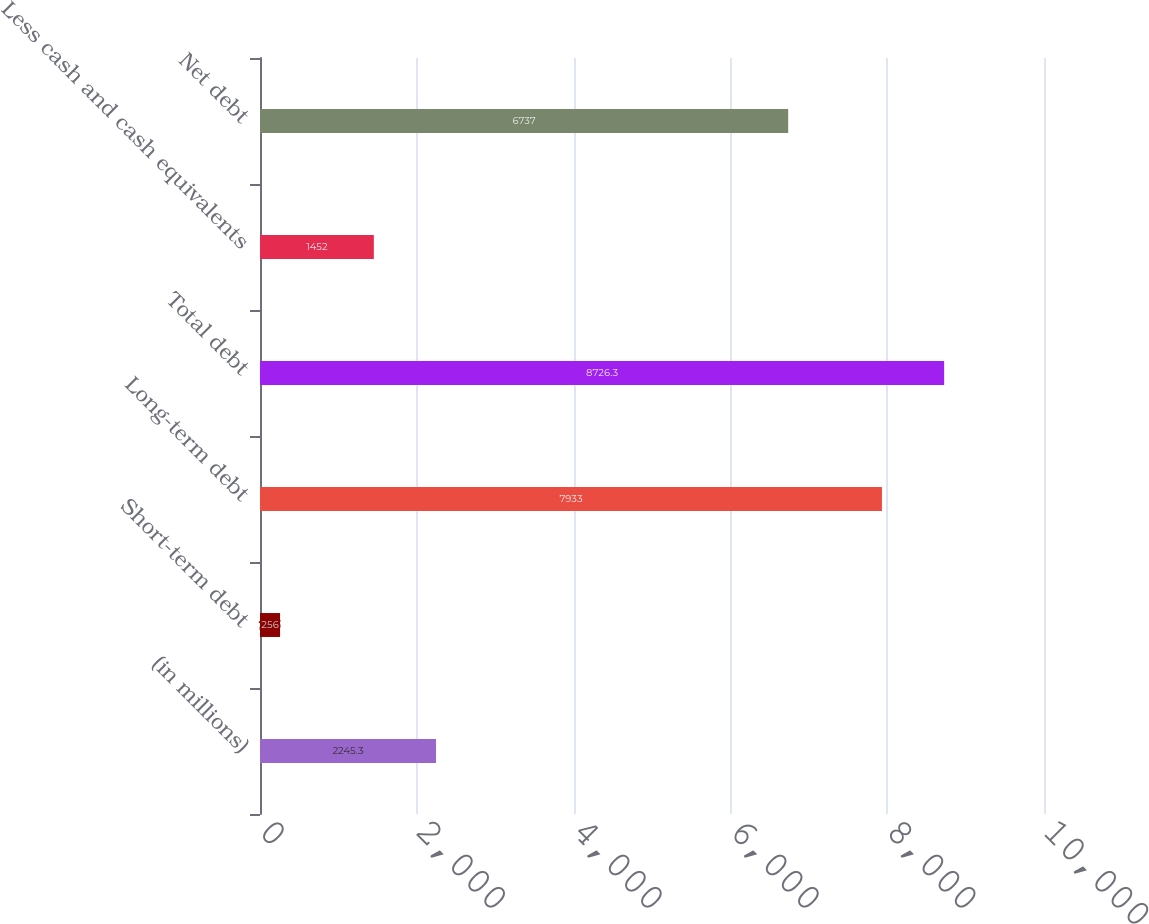<chart> <loc_0><loc_0><loc_500><loc_500><bar_chart><fcel>(in millions)<fcel>Short-term debt<fcel>Long-term debt<fcel>Total debt<fcel>Less cash and cash equivalents<fcel>Net debt<nl><fcel>2245.3<fcel>256<fcel>7933<fcel>8726.3<fcel>1452<fcel>6737<nl></chart> 